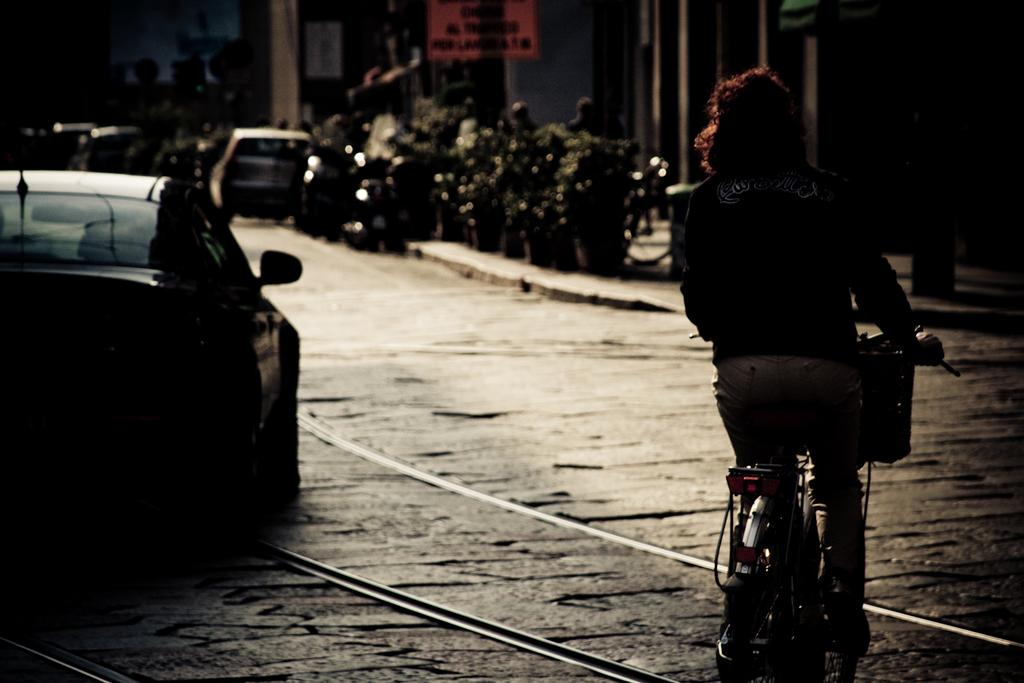What is the main activity of the person in the foreground of the image? The person is cycling in the foreground of the image. Where is the person cycling? The person is on the road. What else can be seen on the left side of the image? There is a car on the left side of the image. What type of scenery is visible in the background of the image? There are plants, vehicles, and buildings in the background of the image. How many hydrants are visible in the image? There are no hydrants visible in the image. What type of clothing is the beggar wearing in the image? There is no beggar present in the image. 